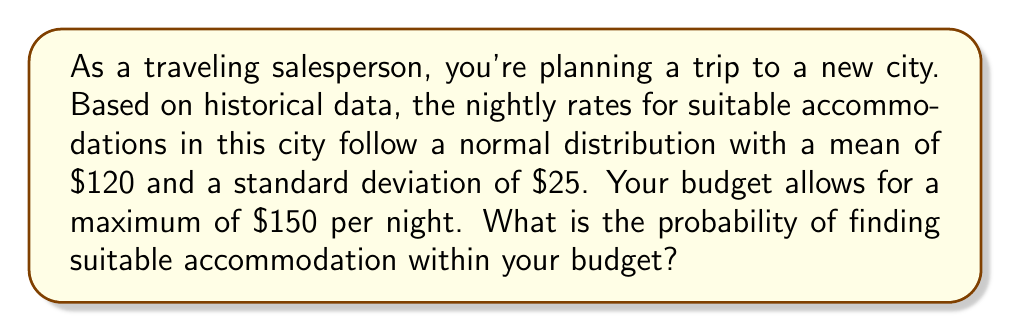Can you solve this math problem? Let's approach this step-by-step:

1) Let X be the random variable representing the nightly rate for suitable accommodations.
   X ~ N($120, $25²)

2) We want to find P(X ≤ $150)

3) To solve this, we need to standardize the random variable:
   Z = (X - μ) / σ
   where Z is the standard normal variable, μ is the mean, and σ is the standard deviation

4) Substituting our values:
   Z = ($150 - $120) / $25 = 30 / 25 = 1.2

5) Now we need to find P(Z ≤ 1.2)

6) Using a standard normal table or calculator, we can find:
   P(Z ≤ 1.2) ≈ 0.8849

7) Therefore, the probability of finding suitable accommodation within the budget is approximately 0.8849 or 88.49%

This can be visualized as the area under the normal curve up to $150:

[asy]
import statistics;
size(200,100);
real f(real x) {return exp(-(x-120)^2/(2*25^2))/(25*sqrt(2pi));}
path g=graph(f,0,240);
fill(g--(240,0)--(0,0)--cycle,paleblue);
fill((graph(f,0,150)--(150,0)--(0,0)--cycle),palegreen);
draw(g);
label("$120",120,S);
label("$150",150,S);
draw((120,0)--(120,f(120)),dashed);
draw((150,0)--(150,f(150)),dashed);
label("88.49%",(75,0.005));
[/asy]
Answer: $P(X \leq \$150) \approx 0.8849$ or $88.49\%$ 